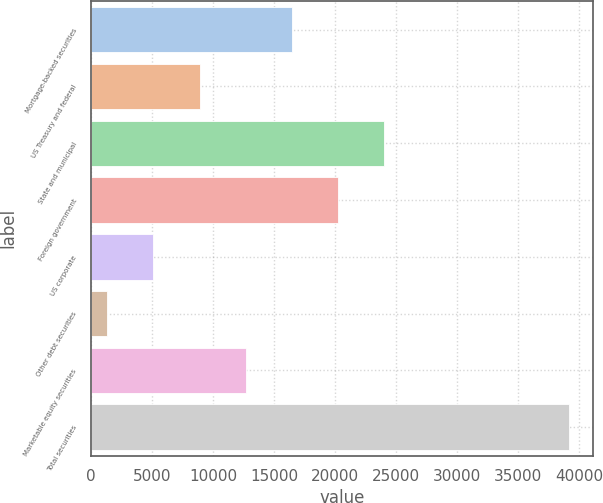Convert chart. <chart><loc_0><loc_0><loc_500><loc_500><bar_chart><fcel>Mortgage-backed securities<fcel>US Treasury and federal<fcel>State and municipal<fcel>Foreign government<fcel>US corporate<fcel>Other debt securities<fcel>Marketable equity securities<fcel>Total securities<nl><fcel>16459.4<fcel>8892.2<fcel>24026.6<fcel>20243<fcel>5108.6<fcel>1325<fcel>12675.8<fcel>39161<nl></chart> 